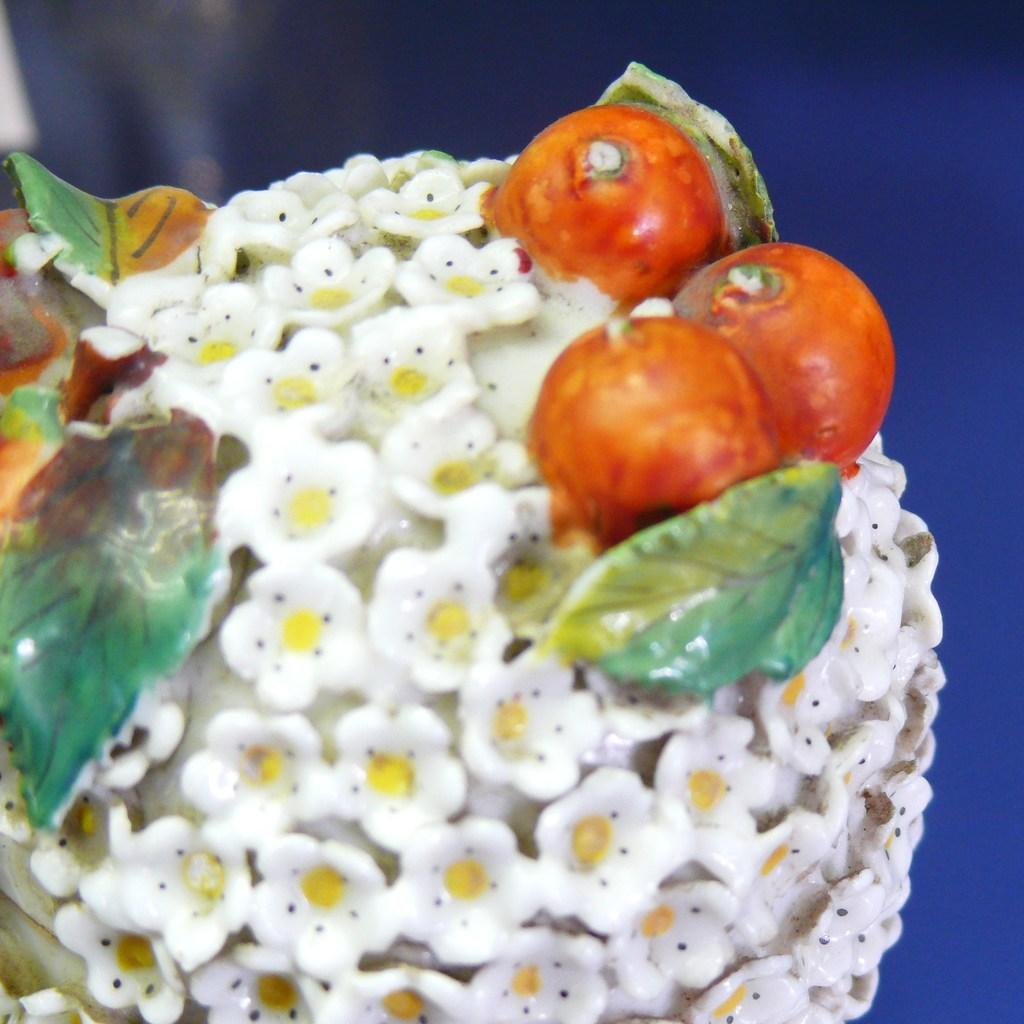What is the primary color of the object in the image? The primary color of the object in the image is white. What types of objects are on the white object? There are green and orange objects on the white object. What color can be seen in the background of the image? The background of the image includes blue color. Can you tell me how many toothbrushes are visible in the image? There are no toothbrushes present in the image. What type of suit is the tiger wearing in the image? There is no tiger or suit present in the image. 